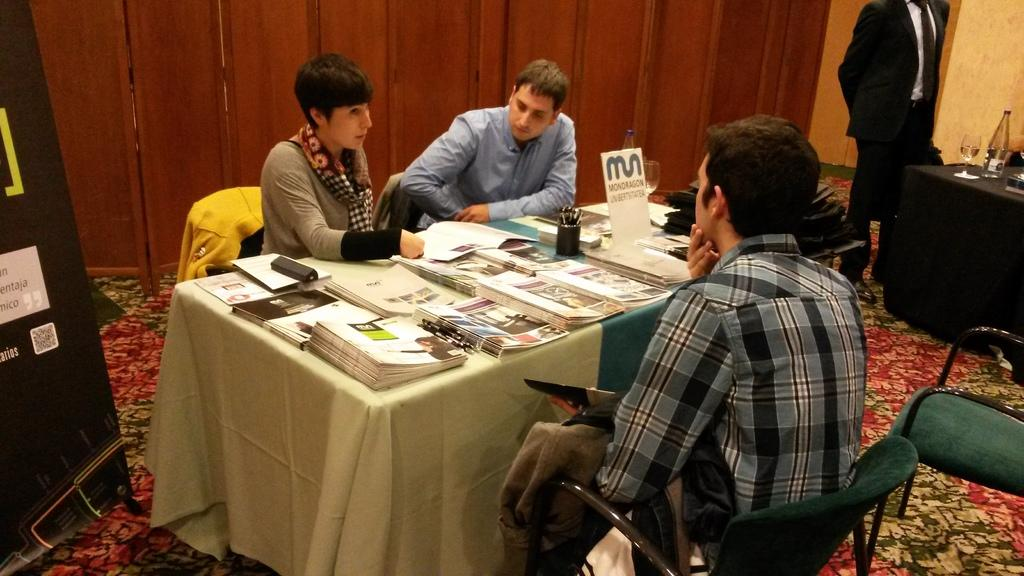What are the people in the image doing? The people in the image are sitting on chairs. Is there anyone standing in the image? Yes, there is a person standing in the image. What is on the table in the image? There are books, a glass, and a bottle on the table. How many items can be seen on the table? There are three items on the table: books, a glass, and a bottle. What type of amusement can be seen in the image? There is no amusement present in the image; it features people sitting and standing, as well as a table with books, a glass, and a bottle. What kind of play is happening in the image? There is no play happening in the image; it is a scene of people sitting and standing, with a table and its contents. 